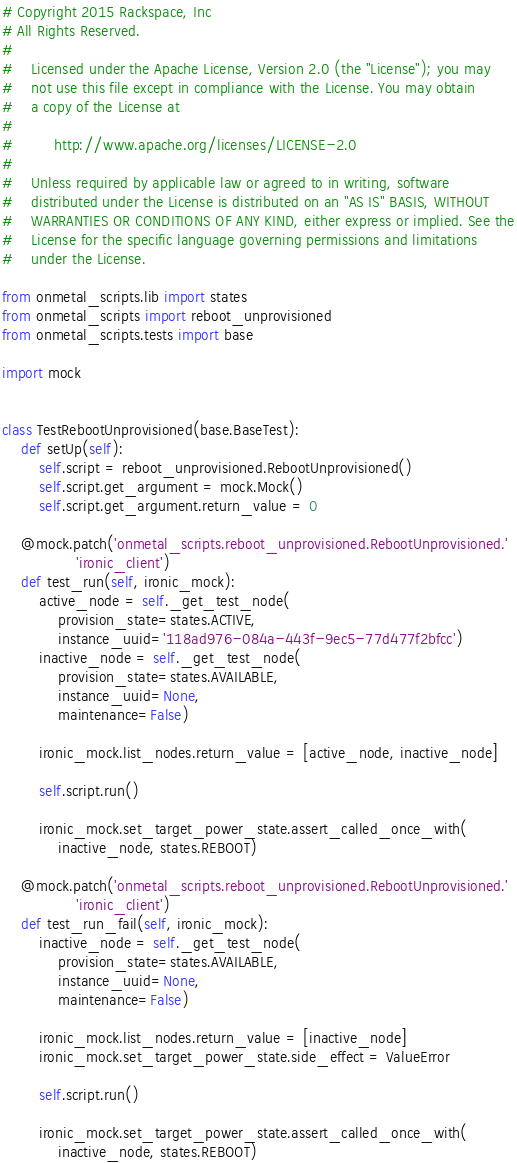Convert code to text. <code><loc_0><loc_0><loc_500><loc_500><_Python_># Copyright 2015 Rackspace, Inc
# All Rights Reserved.
#
#    Licensed under the Apache License, Version 2.0 (the "License"); you may
#    not use this file except in compliance with the License. You may obtain
#    a copy of the License at
#
#         http://www.apache.org/licenses/LICENSE-2.0
#
#    Unless required by applicable law or agreed to in writing, software
#    distributed under the License is distributed on an "AS IS" BASIS, WITHOUT
#    WARRANTIES OR CONDITIONS OF ANY KIND, either express or implied. See the
#    License for the specific language governing permissions and limitations
#    under the License.

from onmetal_scripts.lib import states
from onmetal_scripts import reboot_unprovisioned
from onmetal_scripts.tests import base

import mock


class TestRebootUnprovisioned(base.BaseTest):
    def setUp(self):
        self.script = reboot_unprovisioned.RebootUnprovisioned()
        self.script.get_argument = mock.Mock()
        self.script.get_argument.return_value = 0

    @mock.patch('onmetal_scripts.reboot_unprovisioned.RebootUnprovisioned.'
                'ironic_client')
    def test_run(self, ironic_mock):
        active_node = self._get_test_node(
            provision_state=states.ACTIVE,
            instance_uuid='118ad976-084a-443f-9ec5-77d477f2bfcc')
        inactive_node = self._get_test_node(
            provision_state=states.AVAILABLE,
            instance_uuid=None,
            maintenance=False)

        ironic_mock.list_nodes.return_value = [active_node, inactive_node]

        self.script.run()

        ironic_mock.set_target_power_state.assert_called_once_with(
            inactive_node, states.REBOOT)

    @mock.patch('onmetal_scripts.reboot_unprovisioned.RebootUnprovisioned.'
                'ironic_client')
    def test_run_fail(self, ironic_mock):
        inactive_node = self._get_test_node(
            provision_state=states.AVAILABLE,
            instance_uuid=None,
            maintenance=False)

        ironic_mock.list_nodes.return_value = [inactive_node]
        ironic_mock.set_target_power_state.side_effect = ValueError

        self.script.run()

        ironic_mock.set_target_power_state.assert_called_once_with(
            inactive_node, states.REBOOT)
</code> 